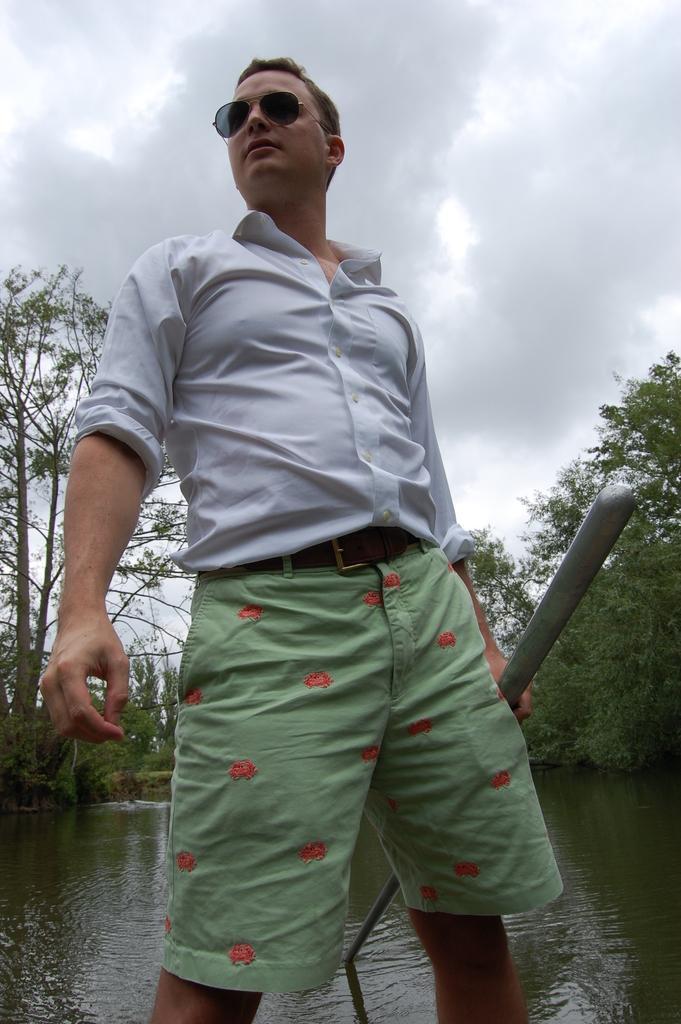How would you summarize this image in a sentence or two? In this image there is one person standing and holding a stick and he is wearing white color shirt and there is a lake at bottom of this image and there are some trees in the background and there is a cloudy sky at top of this image. 